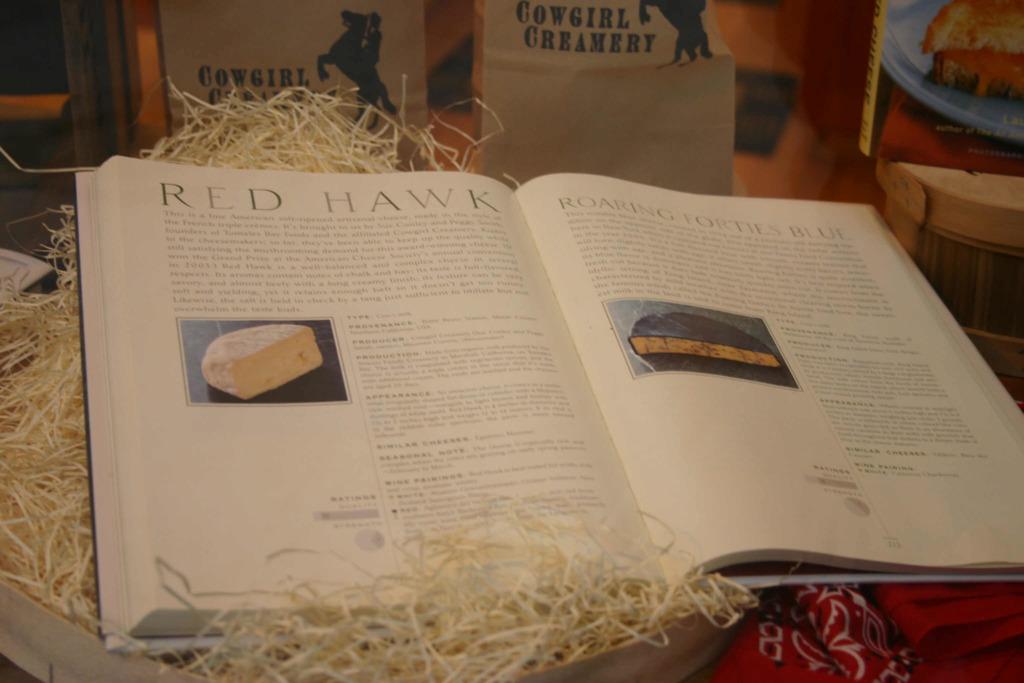What color is written at the top of the page?
Your response must be concise. Red. 